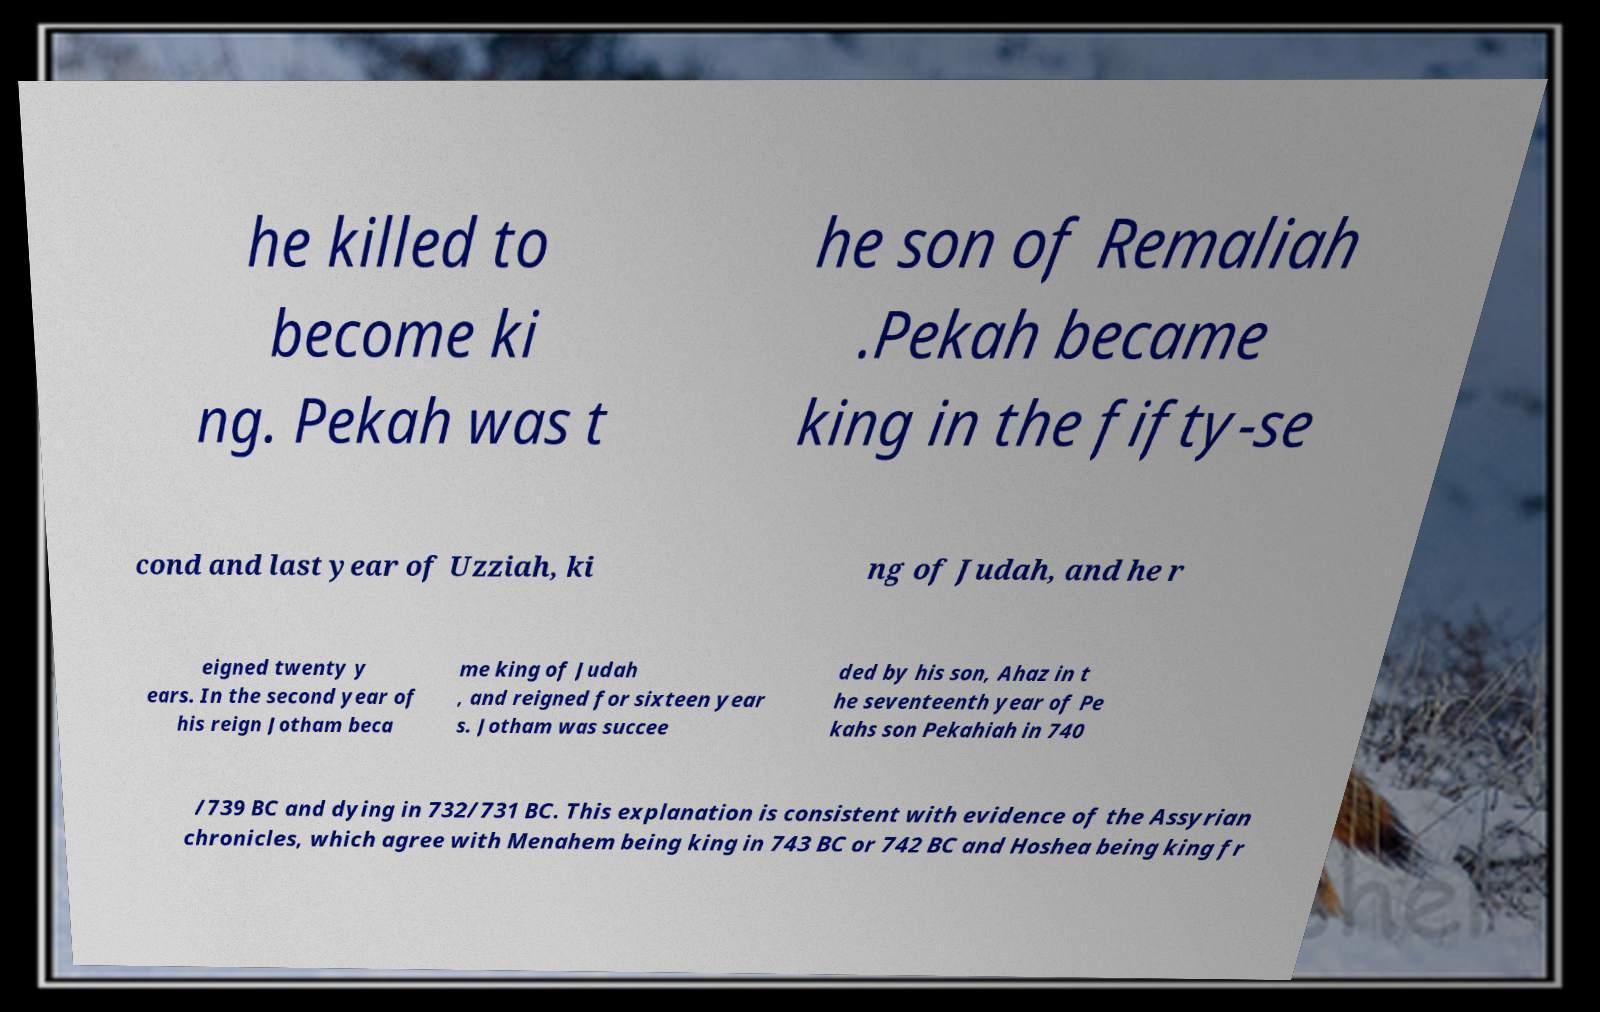Can you read and provide the text displayed in the image?This photo seems to have some interesting text. Can you extract and type it out for me? he killed to become ki ng. Pekah was t he son of Remaliah .Pekah became king in the fifty-se cond and last year of Uzziah, ki ng of Judah, and he r eigned twenty y ears. In the second year of his reign Jotham beca me king of Judah , and reigned for sixteen year s. Jotham was succee ded by his son, Ahaz in t he seventeenth year of Pe kahs son Pekahiah in 740 /739 BC and dying in 732/731 BC. This explanation is consistent with evidence of the Assyrian chronicles, which agree with Menahem being king in 743 BC or 742 BC and Hoshea being king fr 